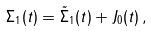Convert formula to latex. <formula><loc_0><loc_0><loc_500><loc_500>\Sigma _ { 1 } ( t ) = \tilde { \Sigma } _ { 1 } ( t ) + J _ { 0 } ( t ) \, ,</formula> 